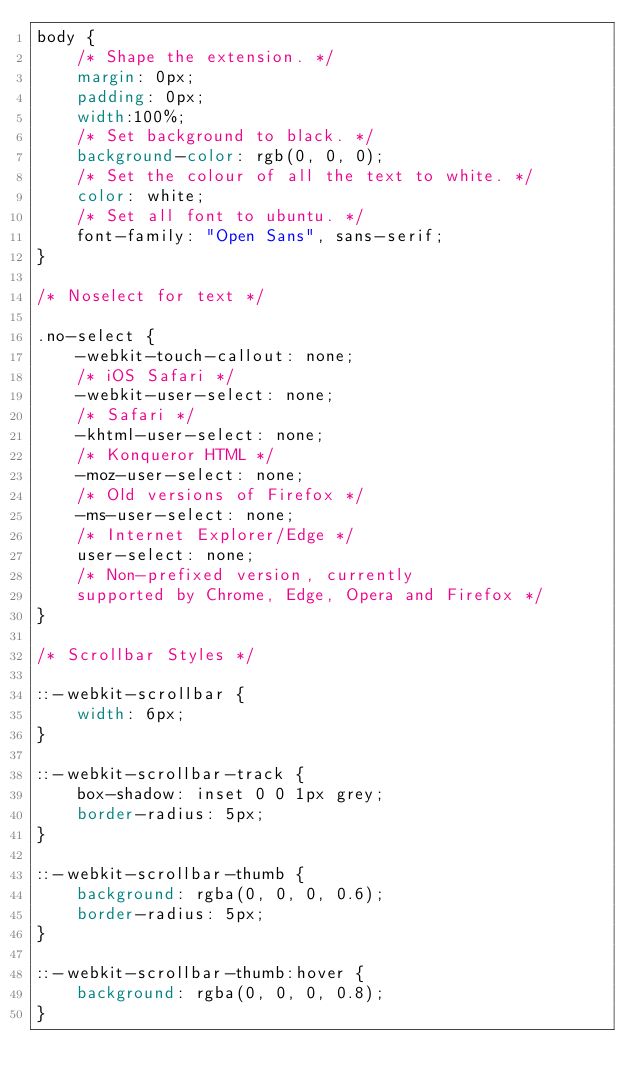<code> <loc_0><loc_0><loc_500><loc_500><_CSS_>body {
    /* Shape the extension. */
    margin: 0px;
    padding: 0px;
    width:100%;
    /* Set background to black. */
    background-color: rgb(0, 0, 0);
    /* Set the colour of all the text to white. */
    color: white;
    /* Set all font to ubuntu. */
    font-family: "Open Sans", sans-serif;
}

/* Noselect for text */

.no-select {
    -webkit-touch-callout: none;
    /* iOS Safari */
    -webkit-user-select: none;
    /* Safari */
    -khtml-user-select: none;
    /* Konqueror HTML */
    -moz-user-select: none;
    /* Old versions of Firefox */
    -ms-user-select: none;
    /* Internet Explorer/Edge */
    user-select: none;
    /* Non-prefixed version, currently
    supported by Chrome, Edge, Opera and Firefox */
}

/* Scrollbar Styles */

::-webkit-scrollbar {
    width: 6px;
}

::-webkit-scrollbar-track {
    box-shadow: inset 0 0 1px grey;
    border-radius: 5px;
}

::-webkit-scrollbar-thumb {
    background: rgba(0, 0, 0, 0.6);
    border-radius: 5px;
}

::-webkit-scrollbar-thumb:hover {
    background: rgba(0, 0, 0, 0.8);
}</code> 